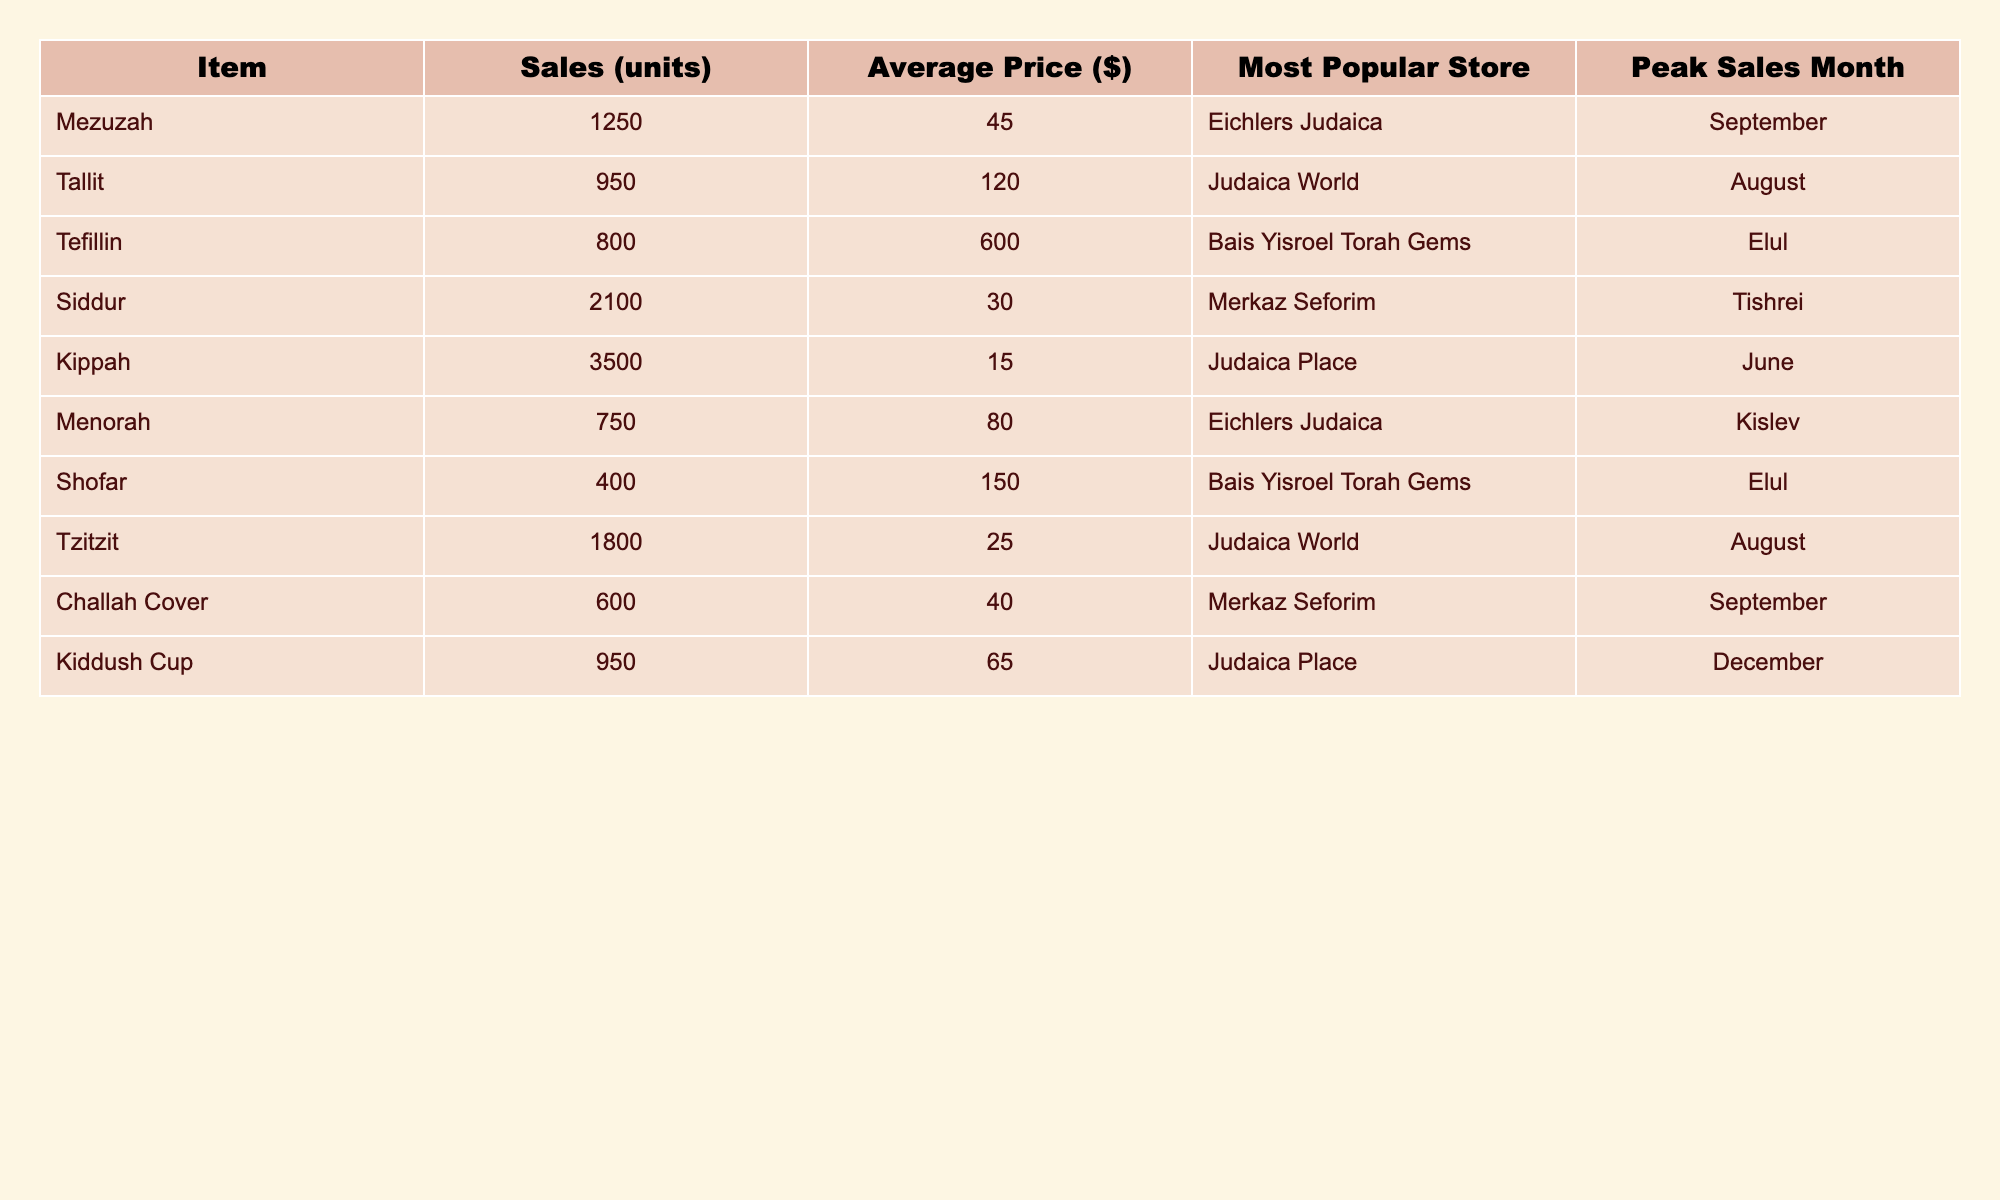What is the most popular store for selling Kippahs? The table indicates that the most popular store for Kippahs is "Judaica Place."
Answer: Judaica Place How many units of Siddur were sold? According to the table, the sales units for Siddur are listed as 2100.
Answer: 2100 What is the average price of a Mezuzah? The average price listed for a Mezuzah in the table is $45.
Answer: 45 Which item had the lowest sales units? By examining the sales units, the item with the lowest sales is Menorah, with 750 units sold.
Answer: Menorah In which month were the most Kippahs sold? The table shows that Kippahs had peak sales in June.
Answer: June What is the total number of Tefillin and Shofars sold? Adding the sales units from the table gives 800 (Tefillin) + 400 (Shofar) = 1200 total units sold.
Answer: 1200 Is the average price of a Tallit higher than that of a Kippah? The average price for Tallit is $120, while for Kippah, it is $15, making the statement true.
Answer: Yes What is the peak sales month for the item that sold the most units? Siddur sold the most units (2100) and its peak sales month is Tishrei.
Answer: Tishrei How many more units of Tzitzit were sold compared to Menorah? Tzitzit sales are 1800 and Menorah sales are 750, therefore, 1800 - 750 = 1050 more units were sold of Tzitzit.
Answer: 1050 Is the average price of a Shofar less than $200? The average price of a Shofar is $150, which is less than $200; thus, the statement is true.
Answer: Yes 